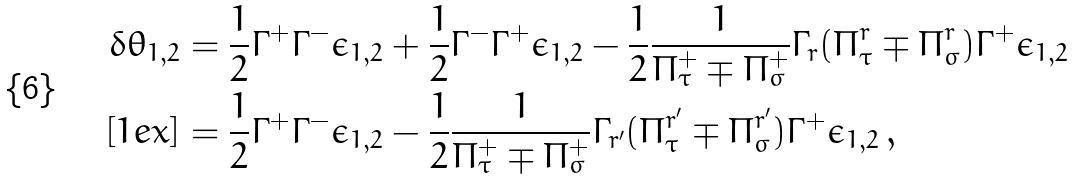Convert formula to latex. <formula><loc_0><loc_0><loc_500><loc_500>\delta \theta _ { 1 , 2 } & = \frac { 1 } { 2 } \Gamma ^ { + } \Gamma ^ { - } \epsilon _ { 1 , 2 } + \frac { 1 } { 2 } \Gamma ^ { - } \Gamma ^ { + } \epsilon _ { 1 , 2 } - \frac { 1 } { 2 } \frac { 1 } { \Pi _ { \tau } ^ { + } \mp \Pi _ { \sigma } ^ { + } } \Gamma _ { r } ( \Pi _ { \tau } ^ { r } \mp \Pi _ { \sigma } ^ { r } ) \Gamma ^ { + } \epsilon _ { 1 , 2 } \\ [ 1 e x ] & = \frac { 1 } { 2 } \Gamma ^ { + } \Gamma ^ { - } \epsilon _ { 1 , 2 } - \frac { 1 } { 2 } \frac { 1 } { \Pi _ { \tau } ^ { + } \mp \Pi _ { \sigma } ^ { + } } \Gamma _ { r ^ { \prime } } ( \Pi _ { \tau } ^ { r ^ { \prime } } \mp \Pi _ { \sigma } ^ { r ^ { \prime } } ) \Gamma ^ { + } \epsilon _ { 1 , 2 } \, ,</formula> 